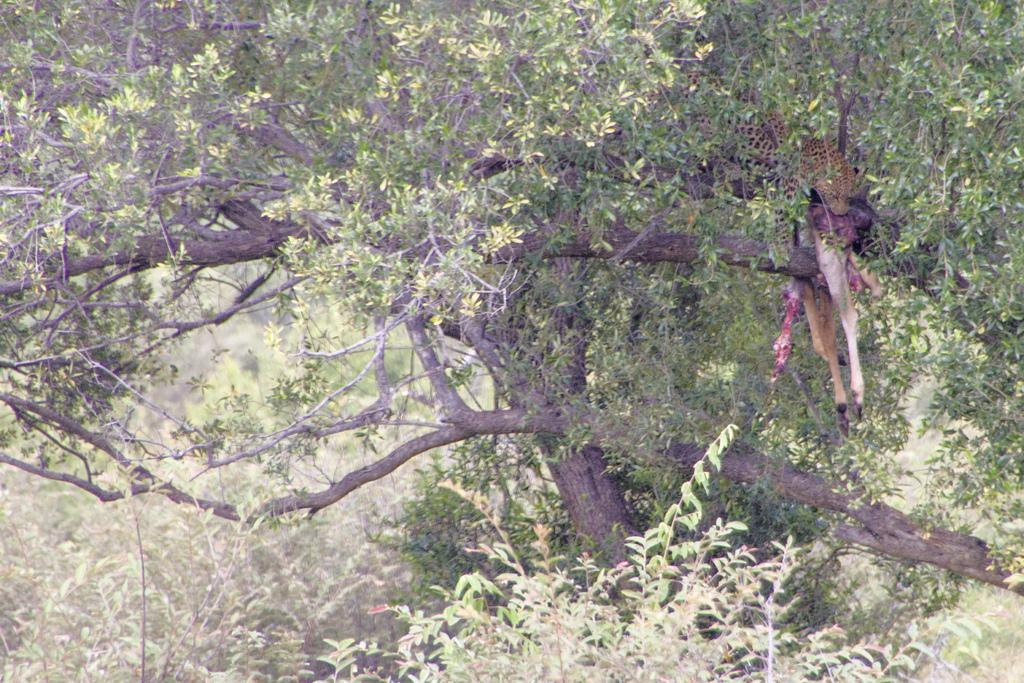What animal is the main subject of the image? There is a cheetah in the image. What is the cheetah doing in the image? The cheetah is eating flesh in the image. What type of vegetation can be seen at the bottom of the image? There is a tree at the bottom of the image. What other natural elements are visible in the image? Bushes are visible in the image. What type of nut is the cheetah holding in its paw in the image? There is no nut present in the image; the cheetah is eating flesh. Can you tell me how many horses are visible in the image? There are no horses present in the image; the main subject is a cheetah. 